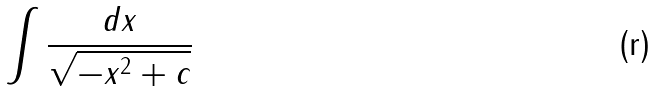<formula> <loc_0><loc_0><loc_500><loc_500>\int { \frac { d x } { \sqrt { - x ^ { 2 } + c } } }</formula> 